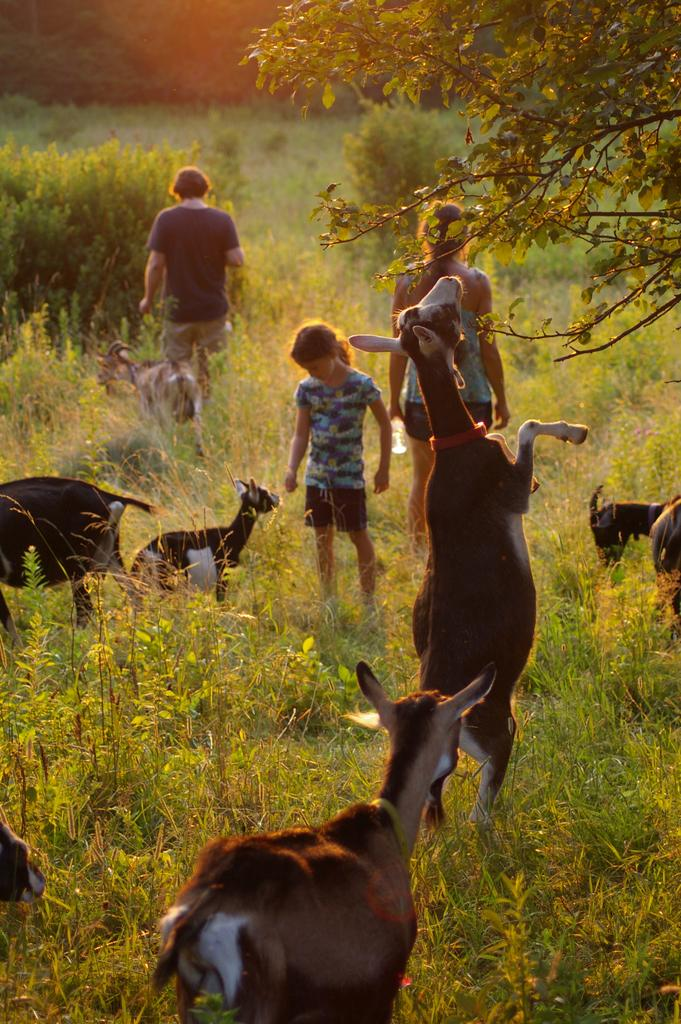Who or what can be seen in the image? There are people and animals in the image. What type of environment is depicted in the image? There is grass at the bottom of the image, suggesting a natural setting. Can you describe any specific features of the image? There is a tree on the right side of the image. What grade does the animal receive for its performance in the image? There is no indication of a performance or grading system in the image, as it simply depicts people and animals in a natural setting. 